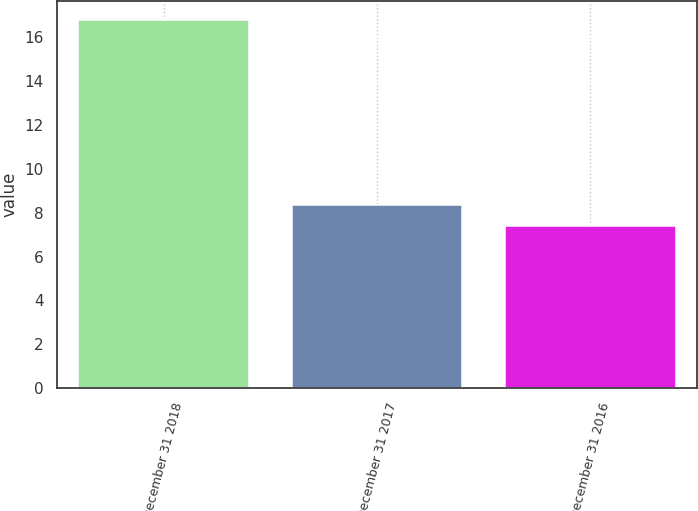<chart> <loc_0><loc_0><loc_500><loc_500><bar_chart><fcel>December 31 2018<fcel>December 31 2017<fcel>December 31 2016<nl><fcel>16.8<fcel>8.34<fcel>7.4<nl></chart> 